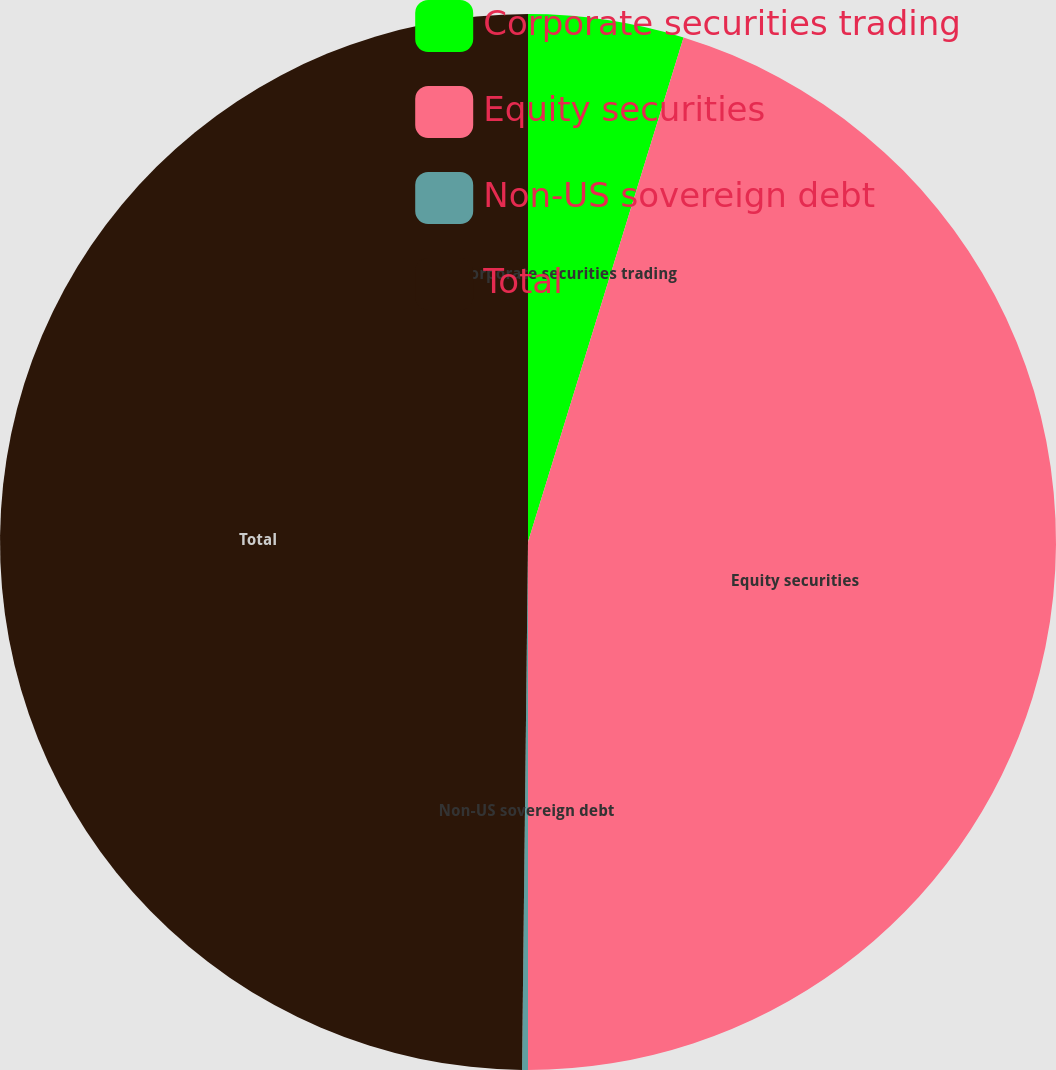Convert chart. <chart><loc_0><loc_0><loc_500><loc_500><pie_chart><fcel>Corporate securities trading<fcel>Equity securities<fcel>Non-US sovereign debt<fcel>Total<nl><fcel>4.76%<fcel>45.24%<fcel>0.18%<fcel>49.82%<nl></chart> 